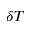Convert formula to latex. <formula><loc_0><loc_0><loc_500><loc_500>\delta { T }</formula> 